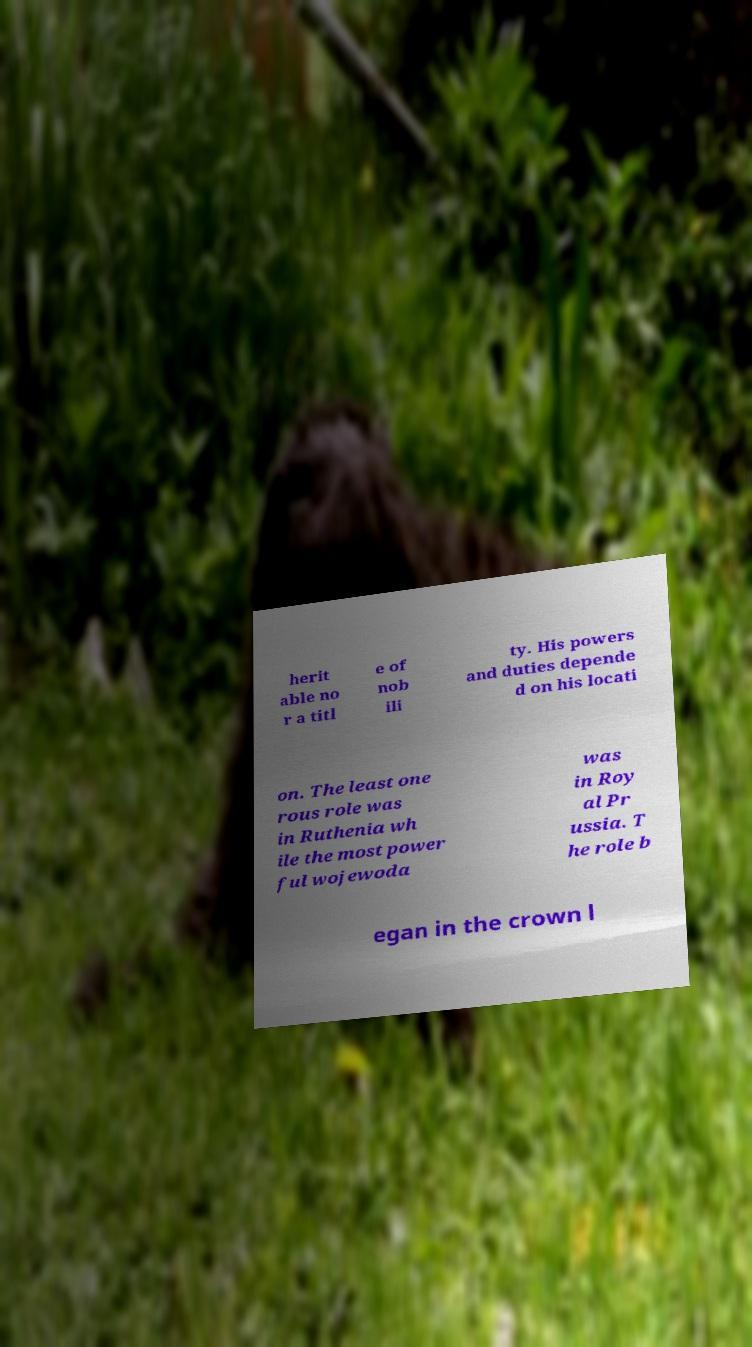Could you extract and type out the text from this image? herit able no r a titl e of nob ili ty. His powers and duties depende d on his locati on. The least one rous role was in Ruthenia wh ile the most power ful wojewoda was in Roy al Pr ussia. T he role b egan in the crown l 